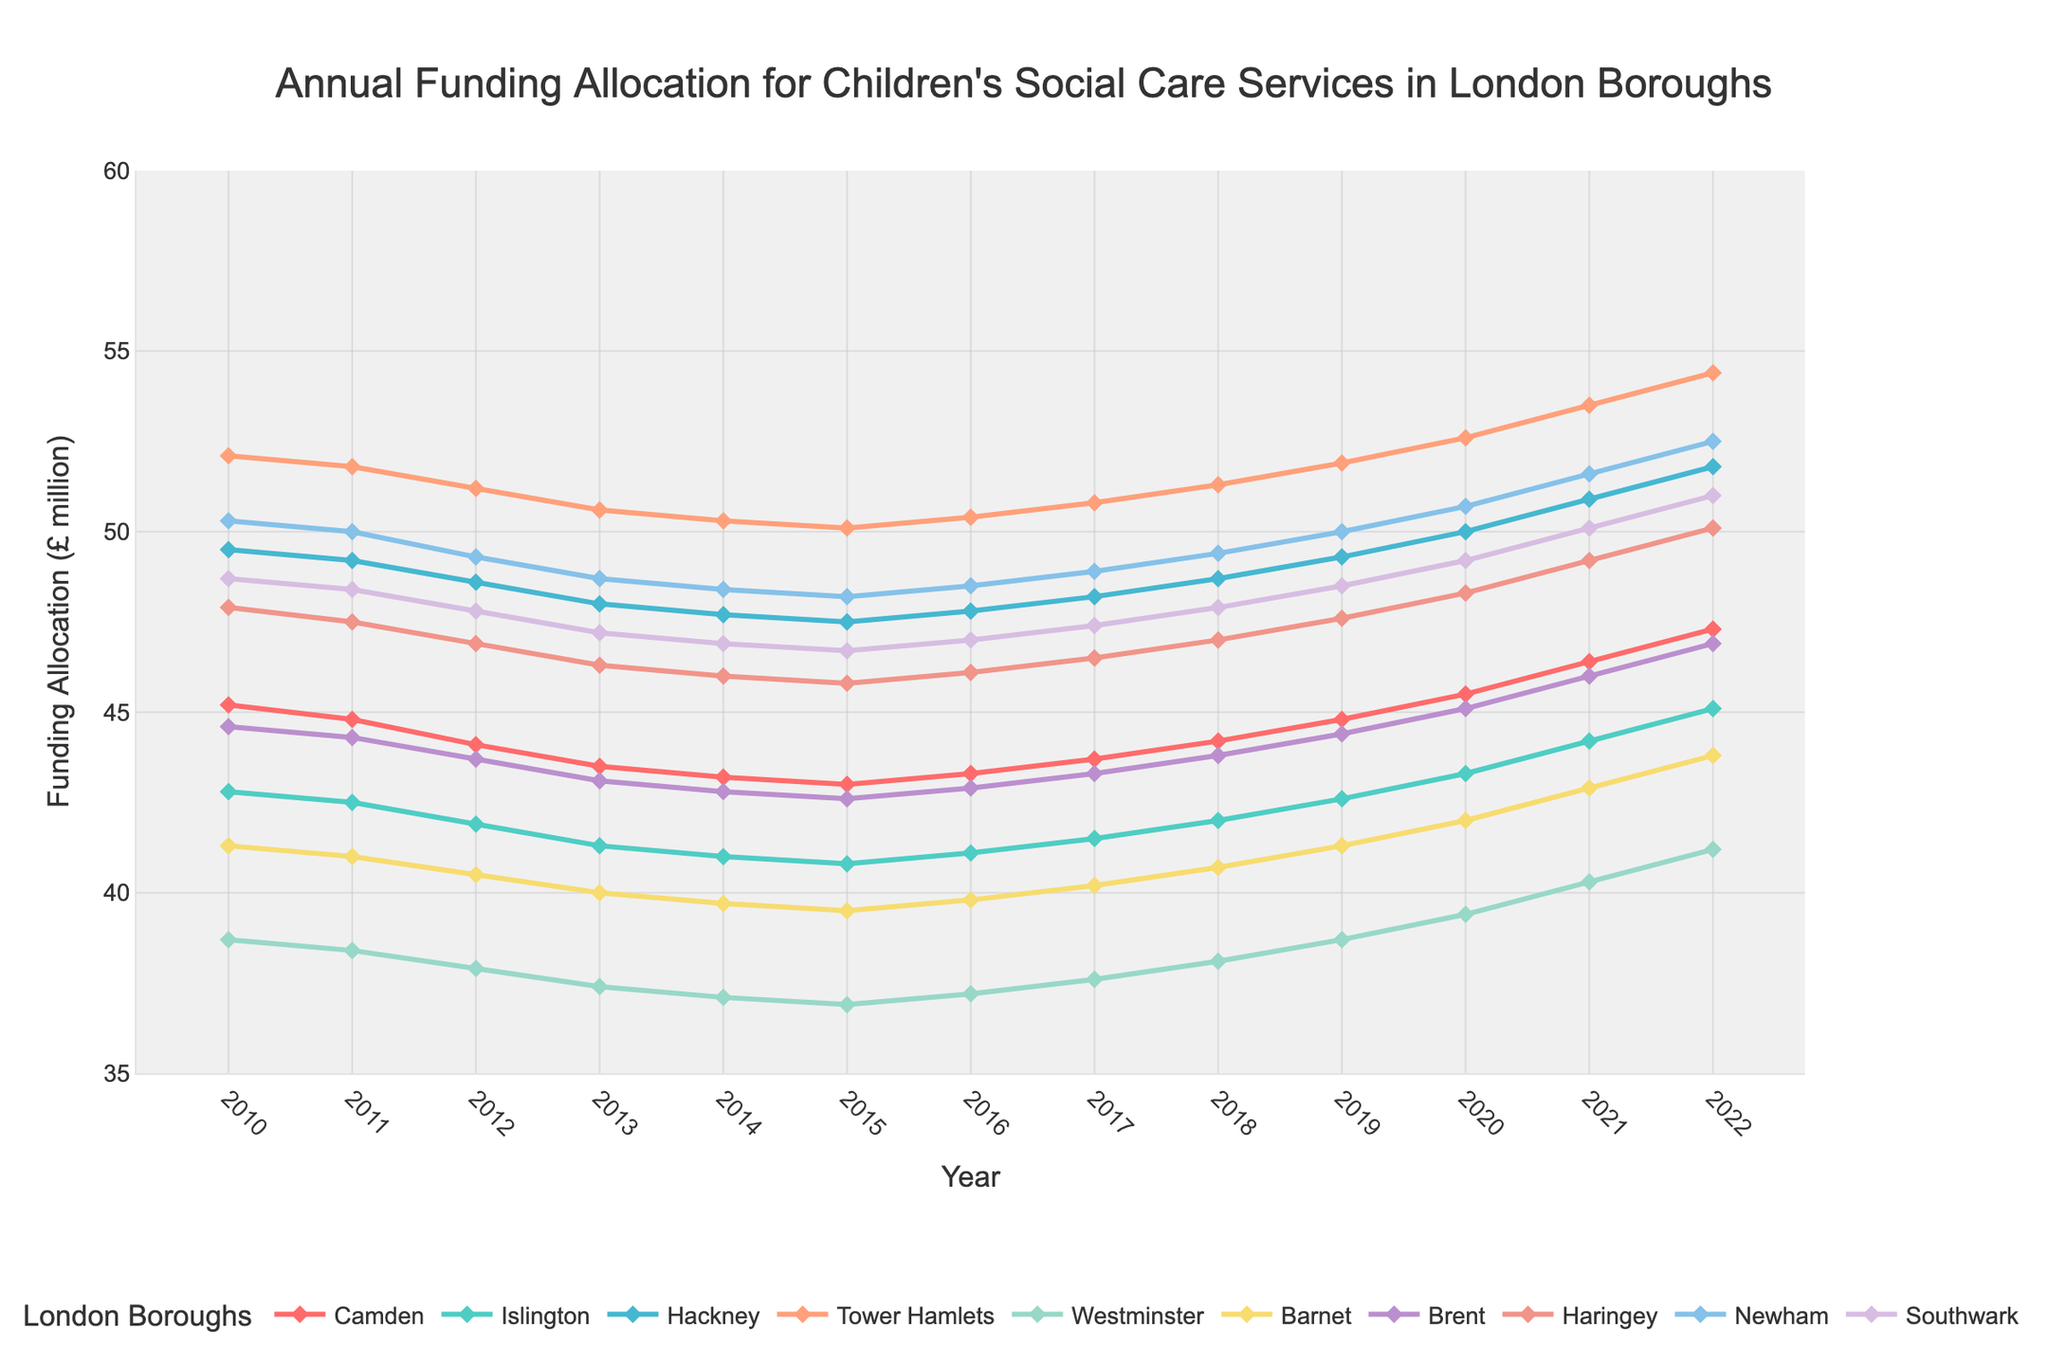Which London borough had the highest funding allocation in 2022? Look at the highest point on the chart in 2022 and see which line it corresponds to. Tower Hamlets is the highest.
Answer: Tower Hamlets Which borough showed a continuous increase in funding allocation from 2010 to 2022? Identify the lines on the chart that show an upward trend year by year from 2010 to 2022. Both Tower Hamlets and Westminster lines increase consistently.
Answer: Tower Hamlets and Westminster Compare the funding allocation of Camden and Islington in 2018. Which borough received more funding? Look at the values for Camden and Islington in 2018. Camden is at 44.2 and Islington is at 42.0.
Answer: Camden How much did the funding allocation for Hackney increase from 2010 to 2022? Subtract Hackney's funding in 2010 (49.5) from its funding in 2022 (51.8). 51.8 - 49.5 = 2.3.
Answer: 2.3 million Which boroughs had funding allocation above 50 million in 2021? Identify the lines that are above the 50 million mark in 2021. Tower Hamlets, Newham, and Hackney are above 50 million.
Answer: Tower Hamlets, Newham, and Hackney In which year did Brent have its lowest funding allocation? Find the lowest point for Brent on the chart and note the corresponding year. Brent's lowest is in 2015 at 42.6.
Answer: 2015 Was there any year when all boroughs had less than 50 million in funding allocation? Check if there is any year where no line crosses the 50 million mark. In 2010, no borough had 50 million or more.
Answer: 2010 What is the difference in funding allocation between Haringey and Barnet in 2022? Subtract Barnet's funding in 2022 (43.8) from Haringey's funding in 2022 (50.1). 50.1 - 43.8 = 6.3.
Answer: 6.3 million Which borough showed the most fluctuation in funding allocation from 2010 to 2022? Identify the line that shows the most up and down movements. While none fluctuate drastically, Camden shows a reasonable level of fluctuation.
Answer: Camden Which borough had the largest single-year increase in funding allocation, and what was the increase? Look for the steepest upward slope between two consecutive years for any given borough. Tower Hamlets had a large increase from 2020 to 2021 (from 52.6 to 53.5), which is 0.9 million.
Answer: Tower Hamlets, 0.9 million 